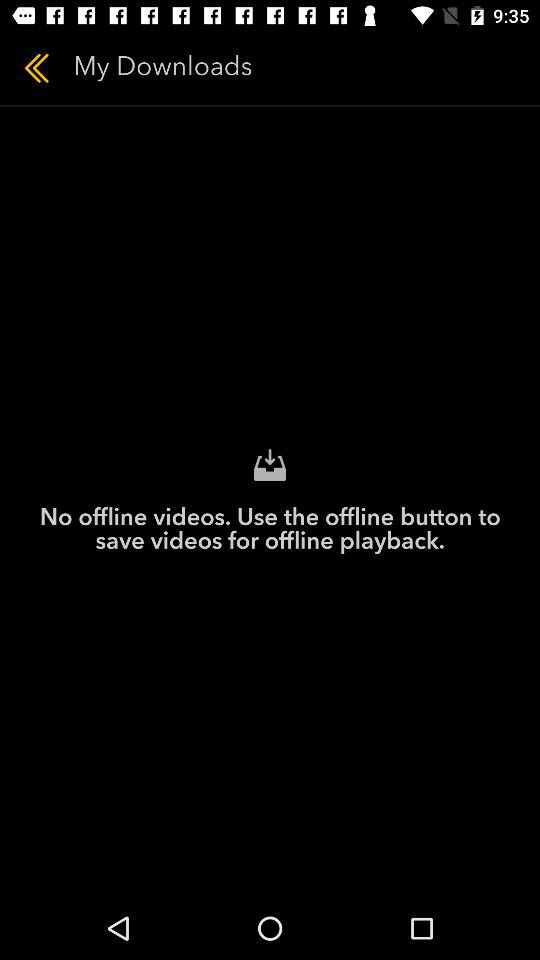What should I do to save the videos offline? You should use the offline button. 